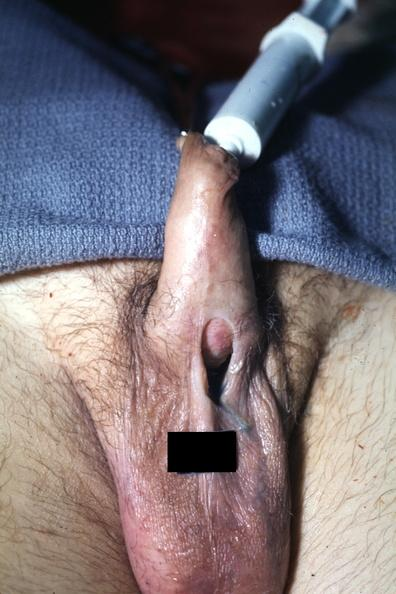what is present?
Answer the question using a single word or phrase. Hypospadias 